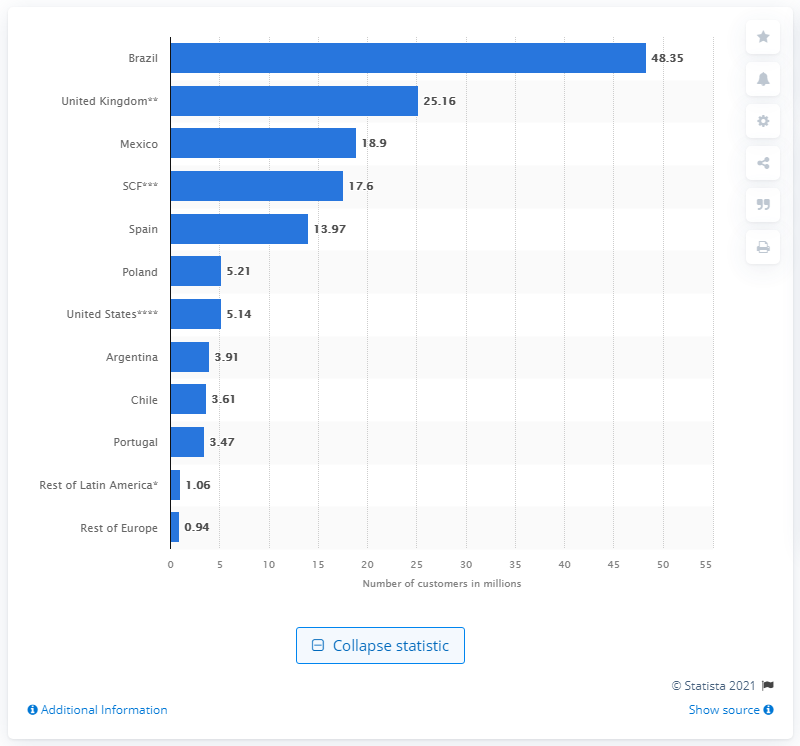Give some essential details in this illustration. In 2020, Banco Santander had a total of 48,350 customers in Brazil. 